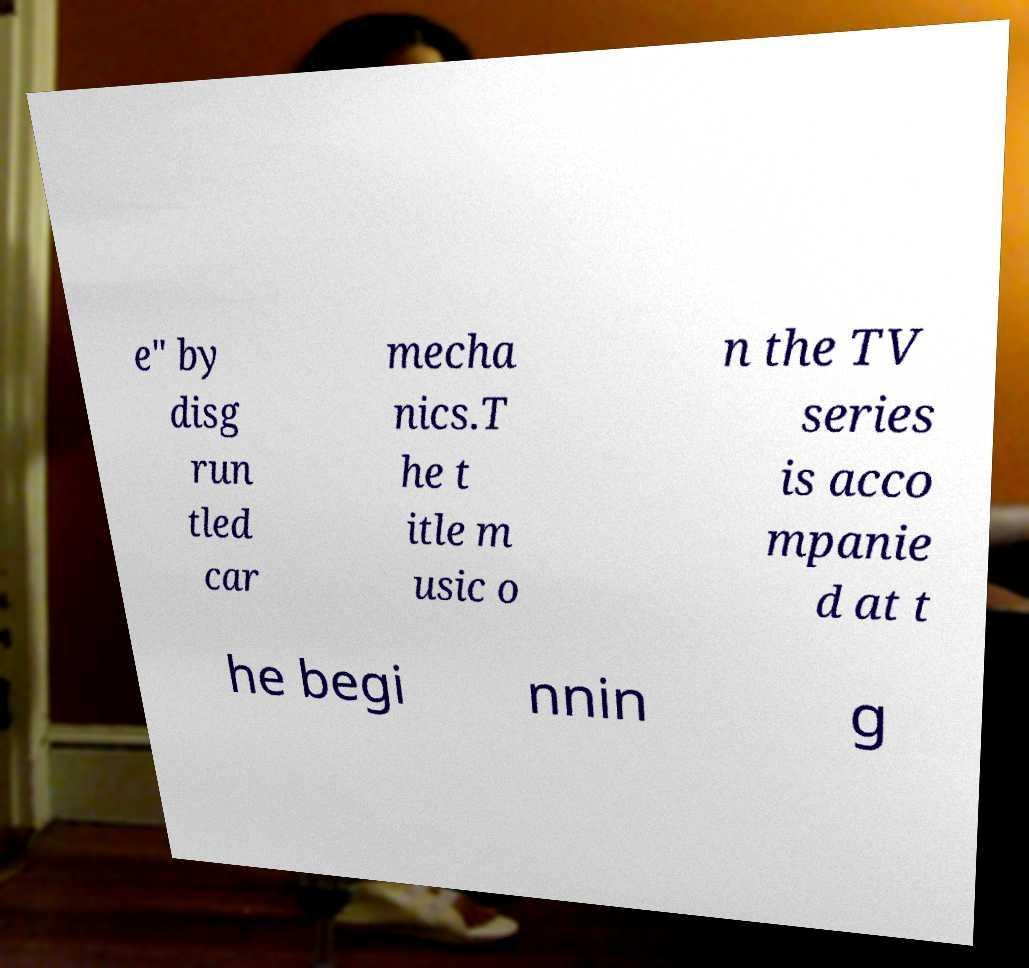Can you accurately transcribe the text from the provided image for me? e" by disg run tled car mecha nics.T he t itle m usic o n the TV series is acco mpanie d at t he begi nnin g 